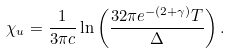<formula> <loc_0><loc_0><loc_500><loc_500>\chi _ { u } = \frac { 1 } { 3 \pi c } \ln \left ( \frac { 3 2 \pi e ^ { - ( 2 + \gamma ) } T } { \Delta } \right ) .</formula> 